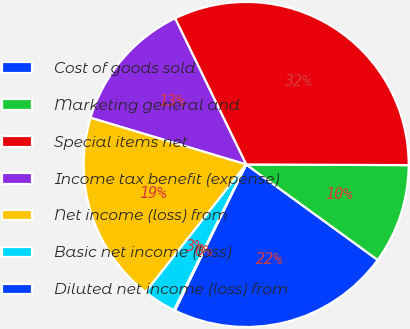<chart> <loc_0><loc_0><loc_500><loc_500><pie_chart><fcel>Cost of goods sold<fcel>Marketing general and<fcel>Special items net<fcel>Income tax benefit (expense)<fcel>Net income (loss) from<fcel>Basic net income (loss)<fcel>Diluted net income (loss) from<nl><fcel>22.23%<fcel>9.93%<fcel>32.27%<fcel>13.16%<fcel>19.01%<fcel>3.31%<fcel>0.09%<nl></chart> 